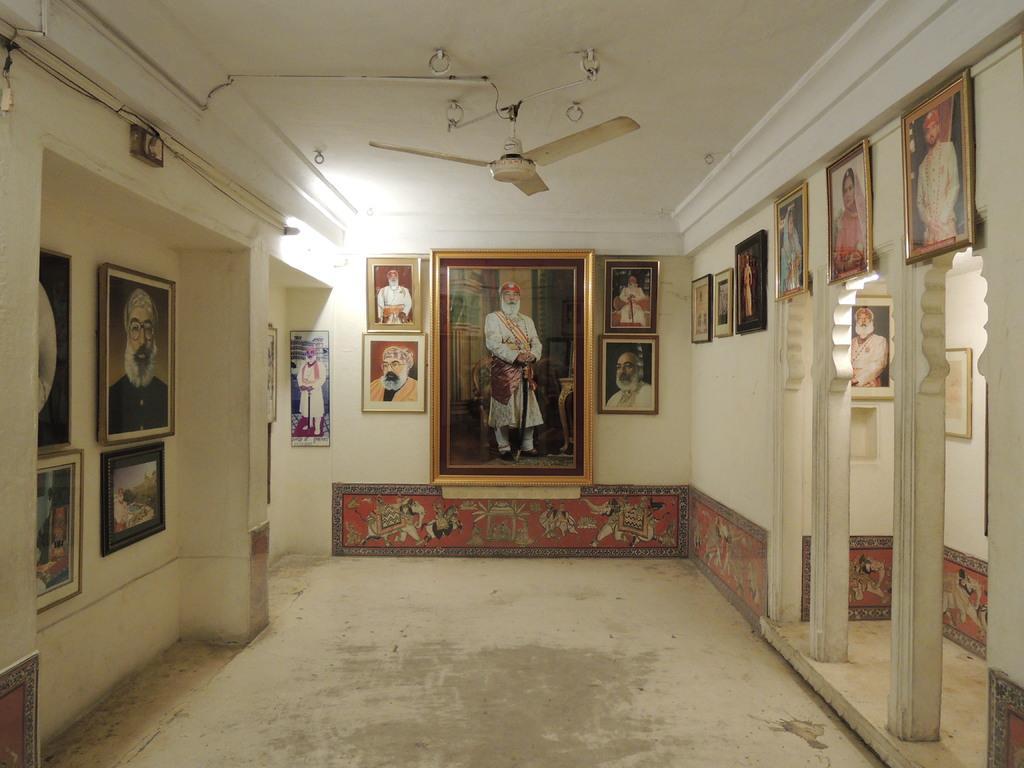Please provide a concise description of this image. In the image there are many photo frames attached to the walls and on the right side there are three pillars, behind the pillars also there are two frames attached to the walls. 